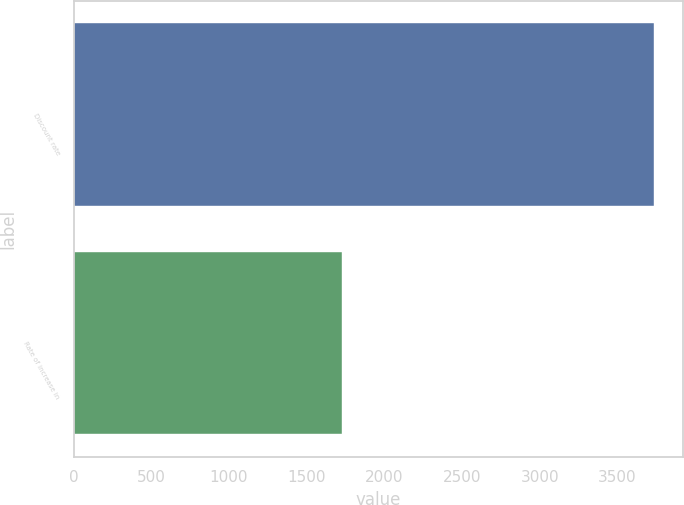Convert chart to OTSL. <chart><loc_0><loc_0><loc_500><loc_500><bar_chart><fcel>Discount rate<fcel>Rate of increase in<nl><fcel>3737<fcel>1726<nl></chart> 